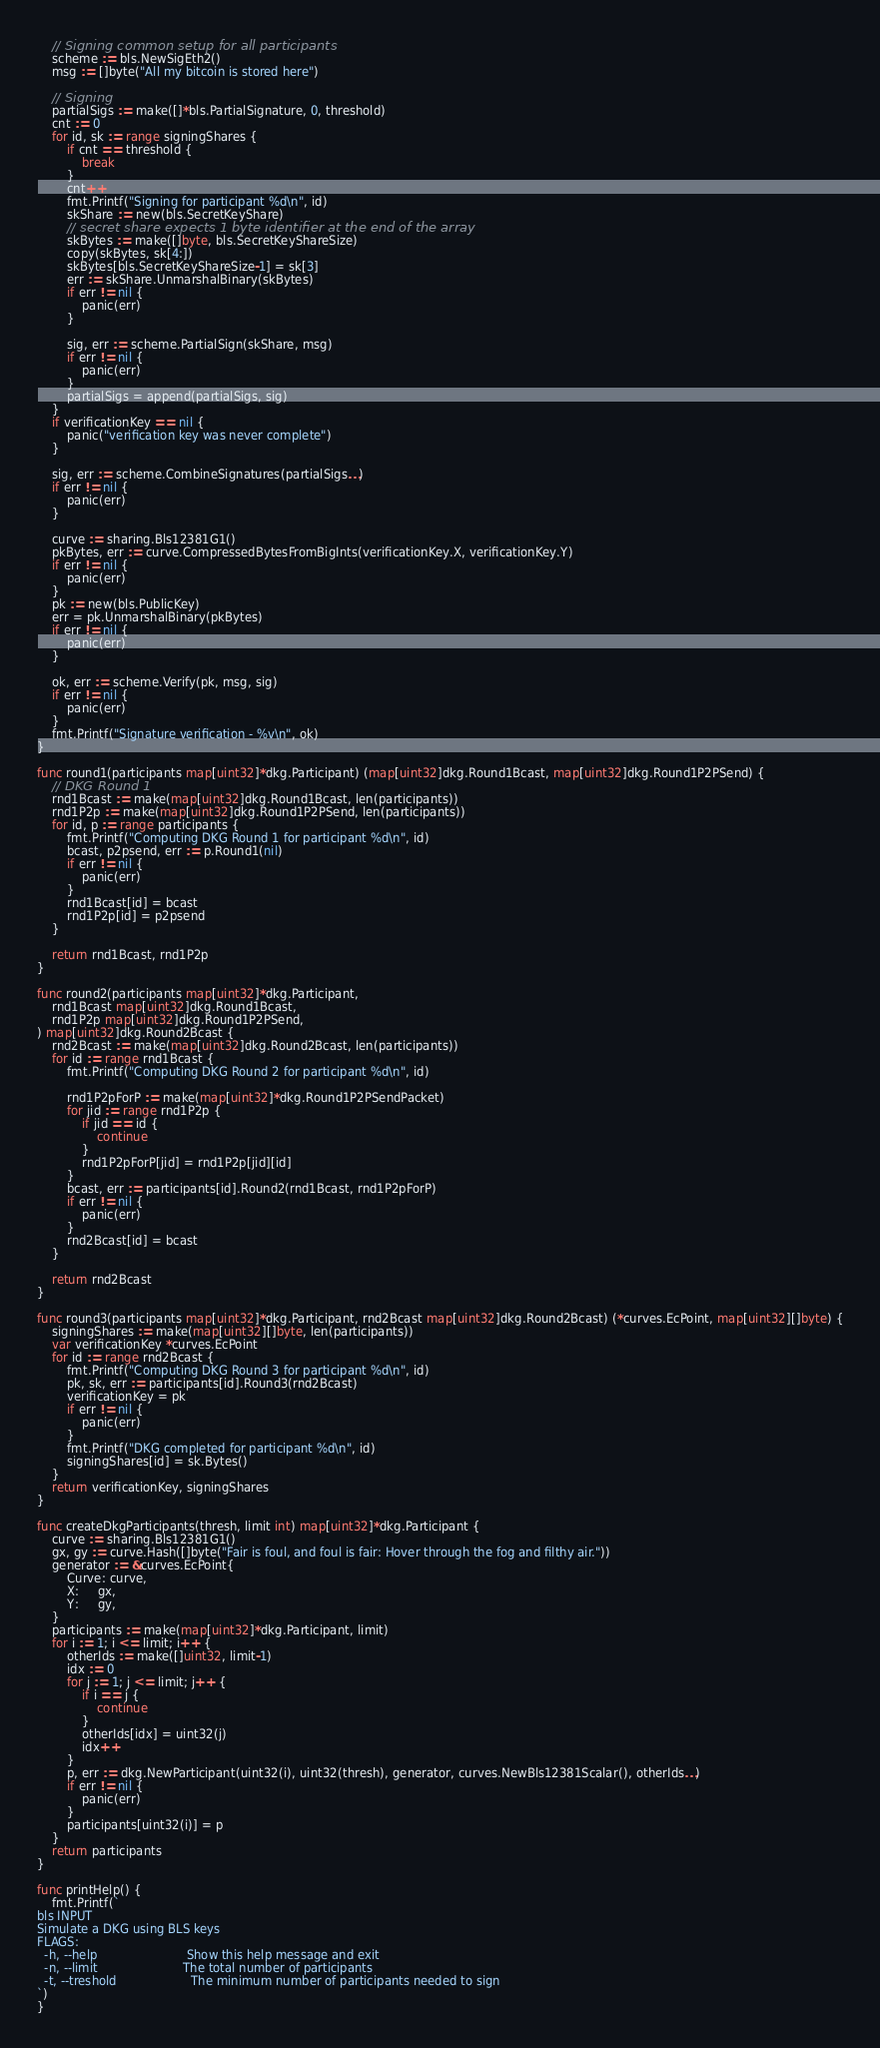<code> <loc_0><loc_0><loc_500><loc_500><_Go_>
	// Signing common setup for all participants
	scheme := bls.NewSigEth2()
	msg := []byte("All my bitcoin is stored here")

	// Signing
	partialSigs := make([]*bls.PartialSignature, 0, threshold)
	cnt := 0
	for id, sk := range signingShares {
		if cnt == threshold {
			break
		}
		cnt++
		fmt.Printf("Signing for participant %d\n", id)
		skShare := new(bls.SecretKeyShare)
		// secret share expects 1 byte identifier at the end of the array
		skBytes := make([]byte, bls.SecretKeyShareSize)
		copy(skBytes, sk[4:])
		skBytes[bls.SecretKeyShareSize-1] = sk[3]
		err := skShare.UnmarshalBinary(skBytes)
		if err != nil {
			panic(err)
		}

		sig, err := scheme.PartialSign(skShare, msg)
		if err != nil {
			panic(err)
		}
		partialSigs = append(partialSigs, sig)
	}
	if verificationKey == nil {
		panic("verification key was never complete")
	}

	sig, err := scheme.CombineSignatures(partialSigs...)
	if err != nil {
		panic(err)
	}

	curve := sharing.Bls12381G1()
	pkBytes, err := curve.CompressedBytesFromBigInts(verificationKey.X, verificationKey.Y)
	if err != nil {
		panic(err)
	}
	pk := new(bls.PublicKey)
	err = pk.UnmarshalBinary(pkBytes)
	if err != nil {
		panic(err)
	}

	ok, err := scheme.Verify(pk, msg, sig)
	if err != nil {
		panic(err)
	}
	fmt.Printf("Signature verification - %v\n", ok)
}

func round1(participants map[uint32]*dkg.Participant) (map[uint32]dkg.Round1Bcast, map[uint32]dkg.Round1P2PSend) {
	// DKG Round 1
	rnd1Bcast := make(map[uint32]dkg.Round1Bcast, len(participants))
	rnd1P2p := make(map[uint32]dkg.Round1P2PSend, len(participants))
	for id, p := range participants {
		fmt.Printf("Computing DKG Round 1 for participant %d\n", id)
		bcast, p2psend, err := p.Round1(nil)
		if err != nil {
			panic(err)
		}
		rnd1Bcast[id] = bcast
		rnd1P2p[id] = p2psend
	}

	return rnd1Bcast, rnd1P2p
}

func round2(participants map[uint32]*dkg.Participant,
	rnd1Bcast map[uint32]dkg.Round1Bcast,
	rnd1P2p map[uint32]dkg.Round1P2PSend,
) map[uint32]dkg.Round2Bcast {
	rnd2Bcast := make(map[uint32]dkg.Round2Bcast, len(participants))
	for id := range rnd1Bcast {
		fmt.Printf("Computing DKG Round 2 for participant %d\n", id)

		rnd1P2pForP := make(map[uint32]*dkg.Round1P2PSendPacket)
		for jid := range rnd1P2p {
			if jid == id {
				continue
			}
			rnd1P2pForP[jid] = rnd1P2p[jid][id]
		}
		bcast, err := participants[id].Round2(rnd1Bcast, rnd1P2pForP)
		if err != nil {
			panic(err)
		}
		rnd2Bcast[id] = bcast
	}

	return rnd2Bcast
}

func round3(participants map[uint32]*dkg.Participant, rnd2Bcast map[uint32]dkg.Round2Bcast) (*curves.EcPoint, map[uint32][]byte) {
	signingShares := make(map[uint32][]byte, len(participants))
	var verificationKey *curves.EcPoint
	for id := range rnd2Bcast {
		fmt.Printf("Computing DKG Round 3 for participant %d\n", id)
		pk, sk, err := participants[id].Round3(rnd2Bcast)
		verificationKey = pk
		if err != nil {
			panic(err)
		}
		fmt.Printf("DKG completed for participant %d\n", id)
		signingShares[id] = sk.Bytes()
	}
	return verificationKey, signingShares
}

func createDkgParticipants(thresh, limit int) map[uint32]*dkg.Participant {
	curve := sharing.Bls12381G1()
	gx, gy := curve.Hash([]byte("Fair is foul, and foul is fair: Hover through the fog and filthy air."))
	generator := &curves.EcPoint{
		Curve: curve,
		X:     gx,
		Y:     gy,
	}
	participants := make(map[uint32]*dkg.Participant, limit)
	for i := 1; i <= limit; i++ {
		otherIds := make([]uint32, limit-1)
		idx := 0
		for j := 1; j <= limit; j++ {
			if i == j {
				continue
			}
			otherIds[idx] = uint32(j)
			idx++
		}
		p, err := dkg.NewParticipant(uint32(i), uint32(thresh), generator, curves.NewBls12381Scalar(), otherIds...)
		if err != nil {
			panic(err)
		}
		participants[uint32(i)] = p
	}
	return participants
}

func printHelp() {
	fmt.Printf(`
bls INPUT
Simulate a DKG using BLS keys
FLAGS:
  -h, --help						Show this help message and exit
  -n, --limit						The total number of participants
  -t, --treshold					The minimum number of participants needed to sign
`)
}
</code> 